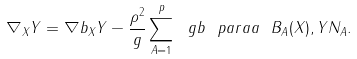Convert formula to latex. <formula><loc_0><loc_0><loc_500><loc_500>\nabla _ { X } Y = \nabla b _ { X } Y - \frac { \rho ^ { 2 } } { g } \sum _ { A = 1 } ^ { p } \ g b \ p a r a a { \ B _ { A } ( X ) , Y } N _ { A } .</formula> 